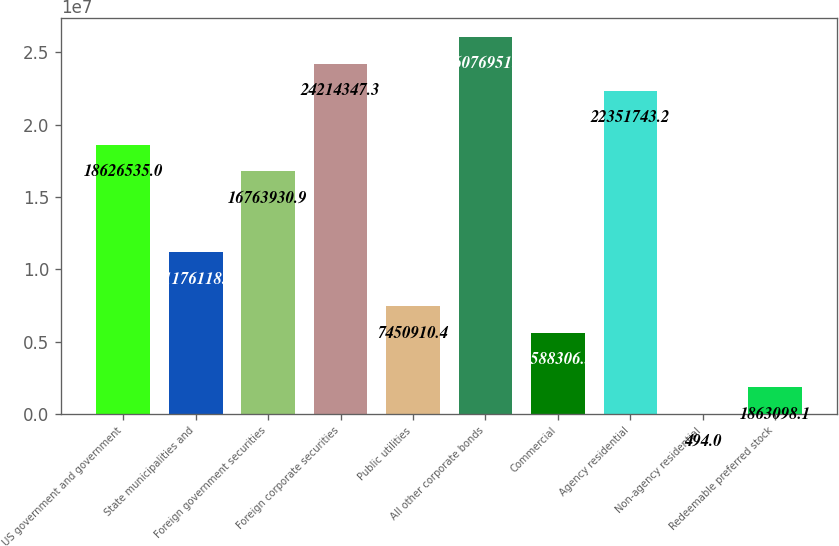Convert chart to OTSL. <chart><loc_0><loc_0><loc_500><loc_500><bar_chart><fcel>US government and government<fcel>State municipalities and<fcel>Foreign government securities<fcel>Foreign corporate securities<fcel>Public utilities<fcel>All other corporate bonds<fcel>Commercial<fcel>Agency residential<fcel>Non-agency residential<fcel>Redeemable preferred stock<nl><fcel>1.86265e+07<fcel>1.11761e+07<fcel>1.67639e+07<fcel>2.42143e+07<fcel>7.45091e+06<fcel>2.6077e+07<fcel>5.58831e+06<fcel>2.23517e+07<fcel>494<fcel>1.8631e+06<nl></chart> 